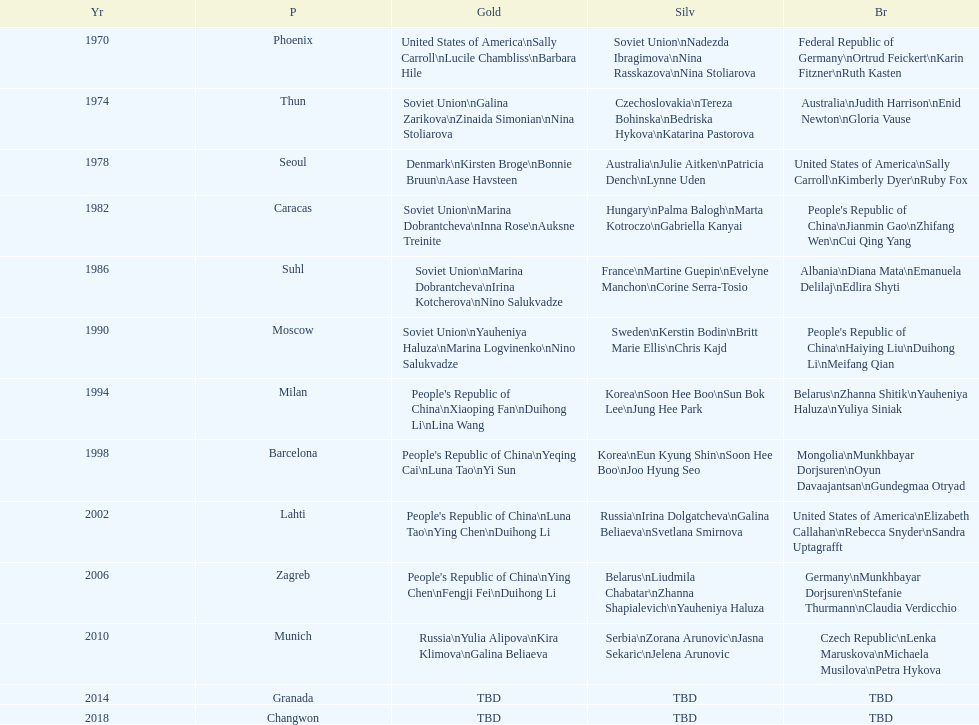How many world championships had the soviet union won first place in in the 25 metre pistol women's world championship? 4. I'm looking to parse the entire table for insights. Could you assist me with that? {'header': ['Yr', 'P', 'Gold', 'Silv', 'Br'], 'rows': [['1970', 'Phoenix', 'United States of America\\nSally Carroll\\nLucile Chambliss\\nBarbara Hile', 'Soviet Union\\nNadezda Ibragimova\\nNina Rasskazova\\nNina Stoliarova', 'Federal Republic of Germany\\nOrtrud Feickert\\nKarin Fitzner\\nRuth Kasten'], ['1974', 'Thun', 'Soviet Union\\nGalina Zarikova\\nZinaida Simonian\\nNina Stoliarova', 'Czechoslovakia\\nTereza Bohinska\\nBedriska Hykova\\nKatarina Pastorova', 'Australia\\nJudith Harrison\\nEnid Newton\\nGloria Vause'], ['1978', 'Seoul', 'Denmark\\nKirsten Broge\\nBonnie Bruun\\nAase Havsteen', 'Australia\\nJulie Aitken\\nPatricia Dench\\nLynne Uden', 'United States of America\\nSally Carroll\\nKimberly Dyer\\nRuby Fox'], ['1982', 'Caracas', 'Soviet Union\\nMarina Dobrantcheva\\nInna Rose\\nAuksne Treinite', 'Hungary\\nPalma Balogh\\nMarta Kotroczo\\nGabriella Kanyai', "People's Republic of China\\nJianmin Gao\\nZhifang Wen\\nCui Qing Yang"], ['1986', 'Suhl', 'Soviet Union\\nMarina Dobrantcheva\\nIrina Kotcherova\\nNino Salukvadze', 'France\\nMartine Guepin\\nEvelyne Manchon\\nCorine Serra-Tosio', 'Albania\\nDiana Mata\\nEmanuela Delilaj\\nEdlira Shyti'], ['1990', 'Moscow', 'Soviet Union\\nYauheniya Haluza\\nMarina Logvinenko\\nNino Salukvadze', 'Sweden\\nKerstin Bodin\\nBritt Marie Ellis\\nChris Kajd', "People's Republic of China\\nHaiying Liu\\nDuihong Li\\nMeifang Qian"], ['1994', 'Milan', "People's Republic of China\\nXiaoping Fan\\nDuihong Li\\nLina Wang", 'Korea\\nSoon Hee Boo\\nSun Bok Lee\\nJung Hee Park', 'Belarus\\nZhanna Shitik\\nYauheniya Haluza\\nYuliya Siniak'], ['1998', 'Barcelona', "People's Republic of China\\nYeqing Cai\\nLuna Tao\\nYi Sun", 'Korea\\nEun Kyung Shin\\nSoon Hee Boo\\nJoo Hyung Seo', 'Mongolia\\nMunkhbayar Dorjsuren\\nOyun Davaajantsan\\nGundegmaa Otryad'], ['2002', 'Lahti', "People's Republic of China\\nLuna Tao\\nYing Chen\\nDuihong Li", 'Russia\\nIrina Dolgatcheva\\nGalina Beliaeva\\nSvetlana Smirnova', 'United States of America\\nElizabeth Callahan\\nRebecca Snyder\\nSandra Uptagrafft'], ['2006', 'Zagreb', "People's Republic of China\\nYing Chen\\nFengji Fei\\nDuihong Li", 'Belarus\\nLiudmila Chabatar\\nZhanna Shapialevich\\nYauheniya Haluza', 'Germany\\nMunkhbayar Dorjsuren\\nStefanie Thurmann\\nClaudia Verdicchio'], ['2010', 'Munich', 'Russia\\nYulia Alipova\\nKira Klimova\\nGalina Beliaeva', 'Serbia\\nZorana Arunovic\\nJasna Sekaric\\nJelena Arunovic', 'Czech Republic\\nLenka Maruskova\\nMichaela Musilova\\nPetra Hykova'], ['2014', 'Granada', 'TBD', 'TBD', 'TBD'], ['2018', 'Changwon', 'TBD', 'TBD', 'TBD']]} 